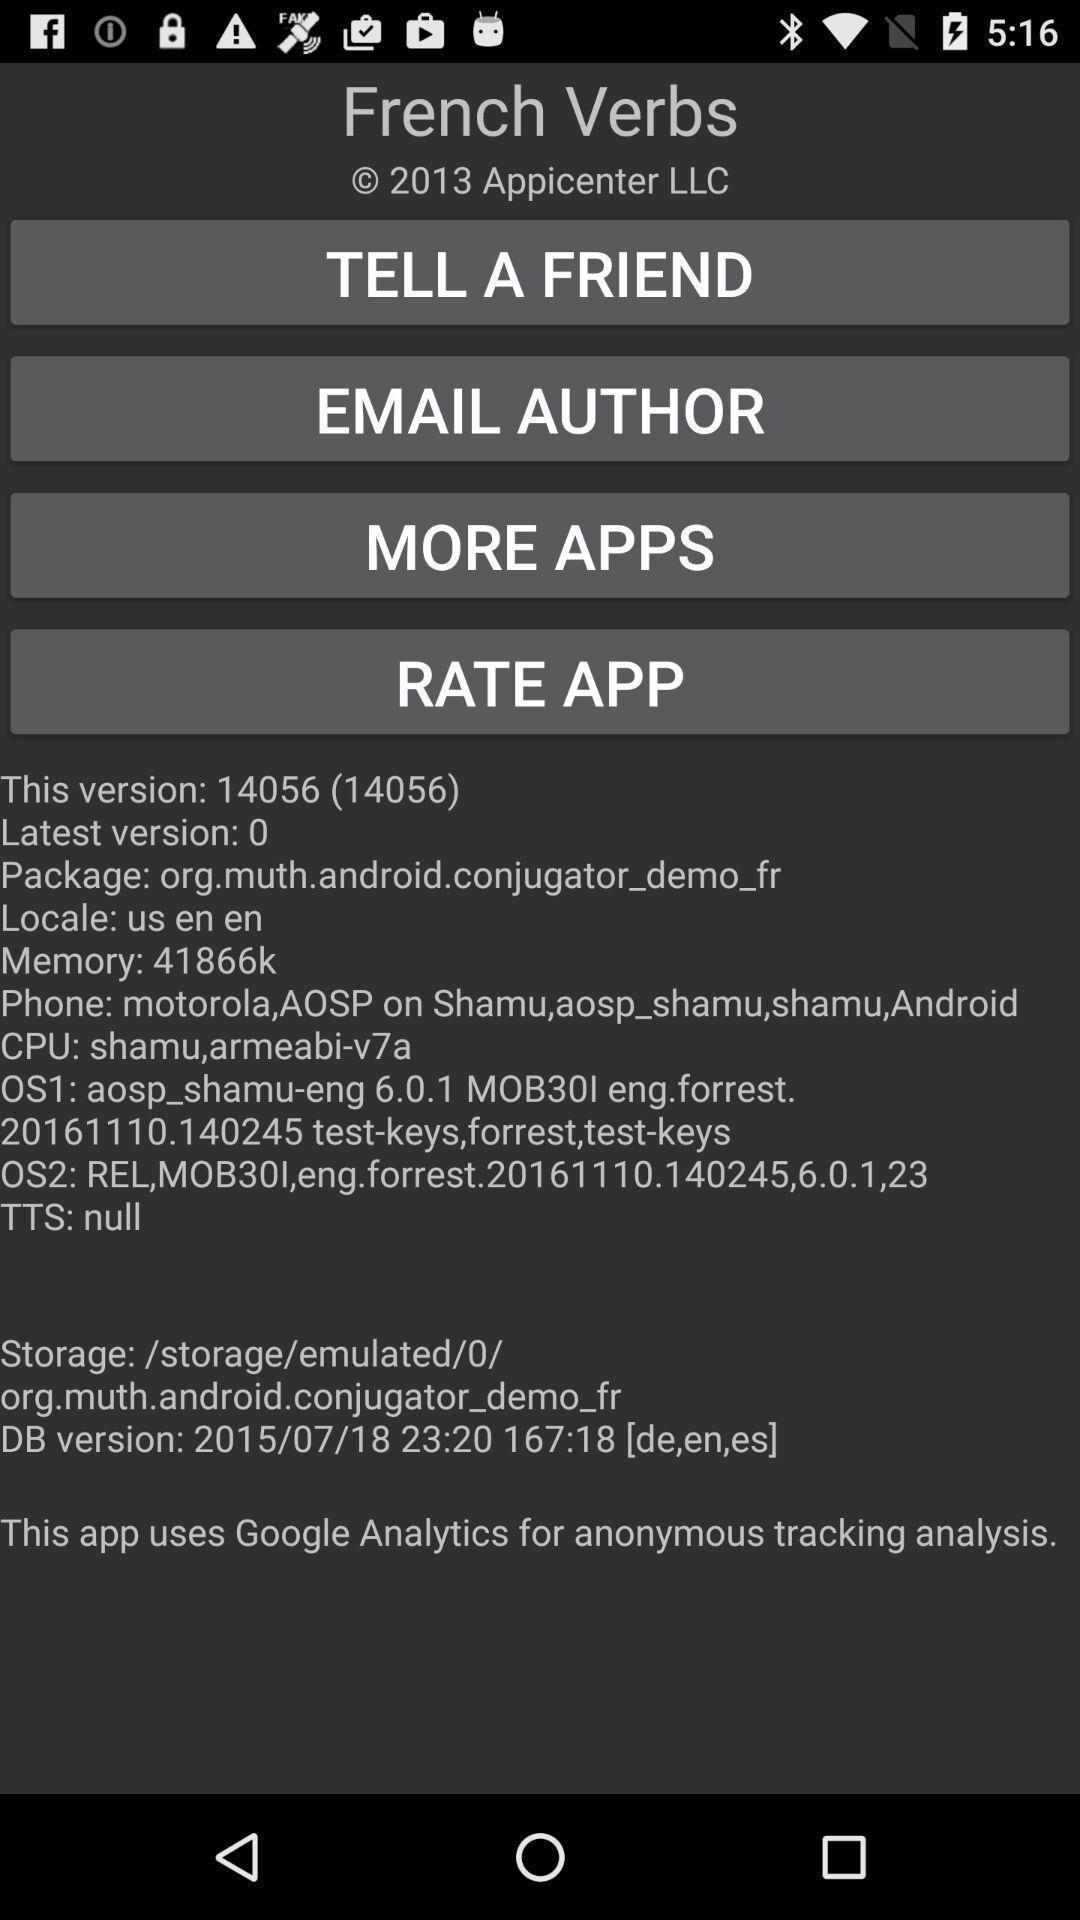Give me a narrative description of this picture. Page showing information of a language learning app. 